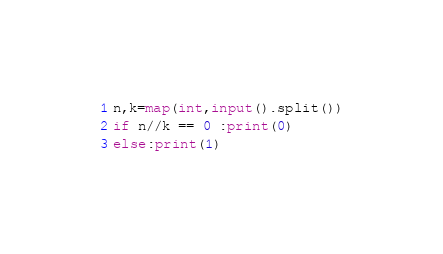<code> <loc_0><loc_0><loc_500><loc_500><_Python_>n,k=map(int,input().split())
if n//k == 0 :print(0)
else:print(1)</code> 